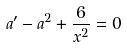Convert formula to latex. <formula><loc_0><loc_0><loc_500><loc_500>a ^ { \prime } - a ^ { 2 } + \frac { 6 } { x ^ { 2 } } = 0</formula> 